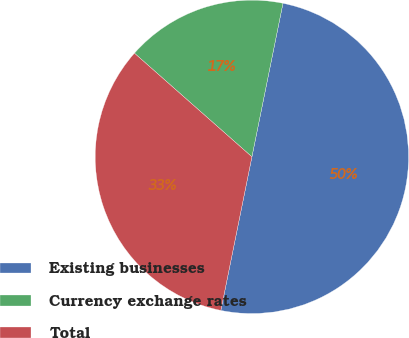Convert chart. <chart><loc_0><loc_0><loc_500><loc_500><pie_chart><fcel>Existing businesses<fcel>Currency exchange rates<fcel>Total<nl><fcel>50.0%<fcel>16.67%<fcel>33.33%<nl></chart> 